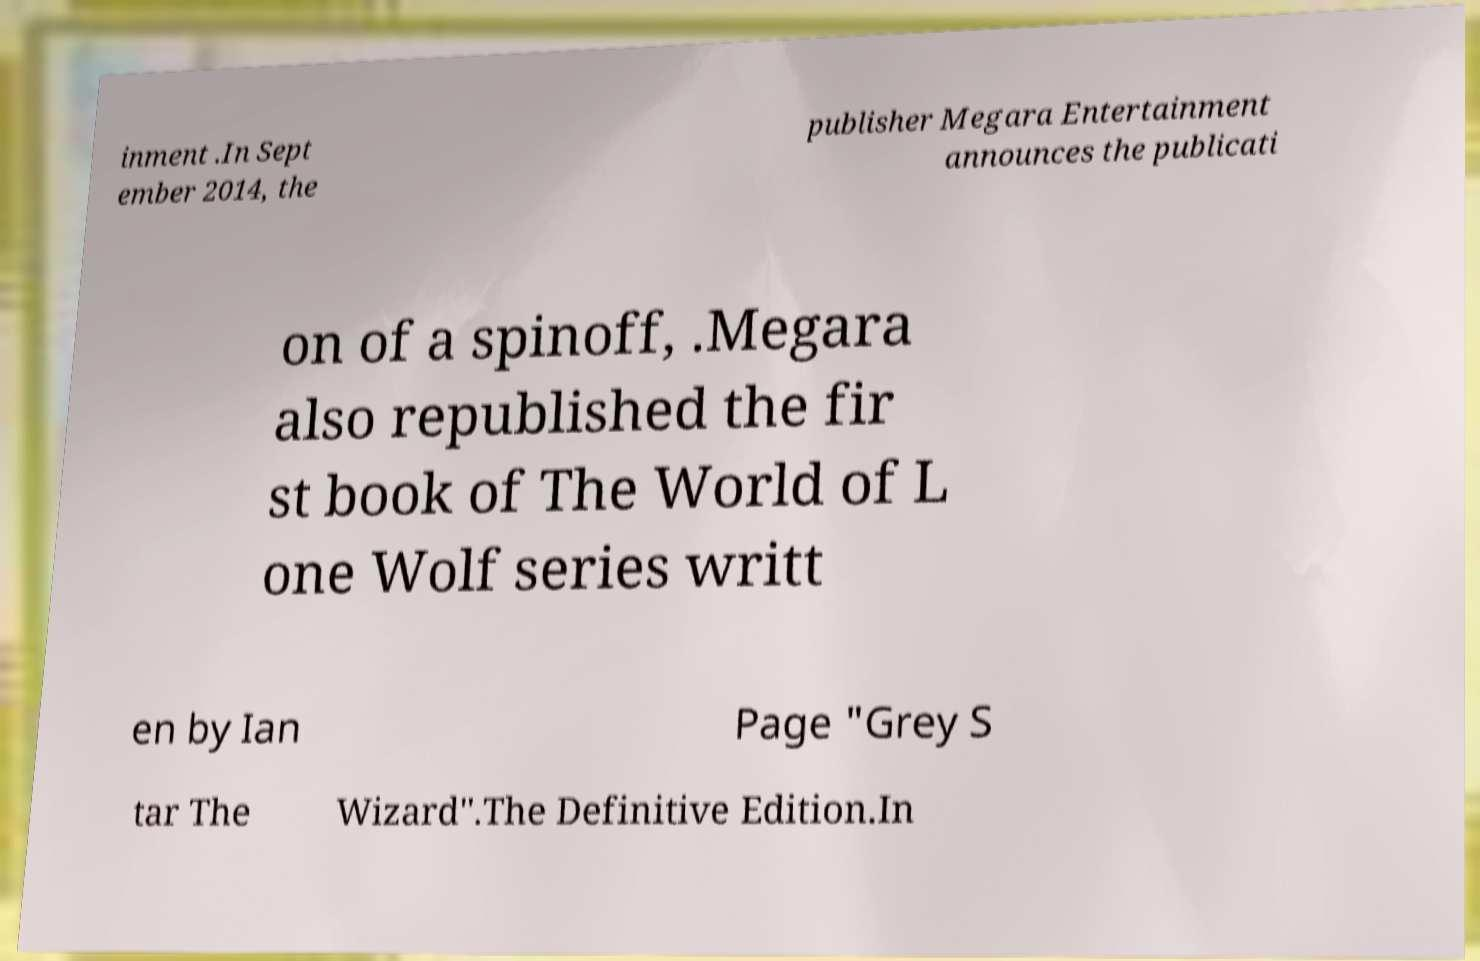Please identify and transcribe the text found in this image. inment .In Sept ember 2014, the publisher Megara Entertainment announces the publicati on of a spinoff, .Megara also republished the fir st book of The World of L one Wolf series writt en by Ian Page "Grey S tar The Wizard".The Definitive Edition.In 